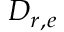Convert formula to latex. <formula><loc_0><loc_0><loc_500><loc_500>D _ { r , e }</formula> 